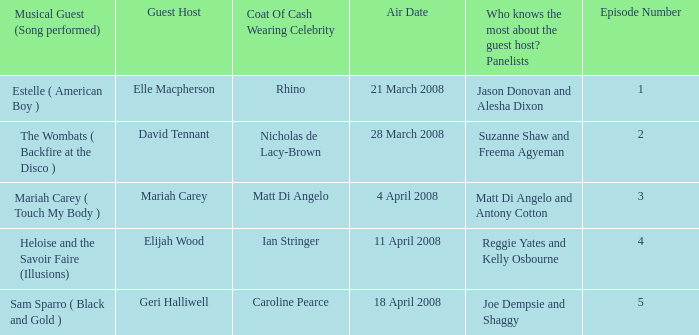Name the total number of episodes for coat of cash wearing celebrity is matt di angelo 1.0. 